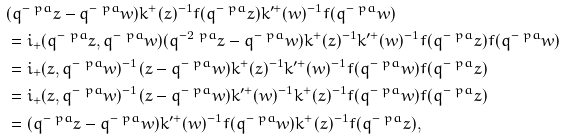<formula> <loc_0><loc_0><loc_500><loc_500>& ( q ^ { - \ p a } z - q ^ { - \ p a } w ) k ^ { + } ( z ) ^ { - 1 } f ( q ^ { - \ p a } z ) k ^ { \prime + } ( w ) ^ { - 1 } f ( q ^ { - \ p a } w ) \\ & = i _ { + } ( q ^ { - \ p a } z , q ^ { - \ p a } w ) ( q ^ { - 2 \ p a } z - q ^ { - \ p a } w ) k ^ { + } ( z ) ^ { - 1 } k ^ { \prime + } ( w ) ^ { - 1 } f ( q ^ { - \ p a } z ) f ( q ^ { - \ p a } w ) \\ & = i _ { + } ( z , q ^ { - \ p a } w ) ^ { - 1 } ( z - q ^ { - \ p a } w ) k ^ { + } ( z ) ^ { - 1 } k ^ { \prime + } ( w ) ^ { - 1 } f ( q ^ { - \ p a } w ) f ( q ^ { - \ p a } z ) \\ & = i _ { + } ( z , q ^ { - \ p a } w ) ^ { - 1 } ( z - q ^ { - \ p a } w ) k ^ { \prime + } ( w ) ^ { - 1 } k ^ { + } ( z ) ^ { - 1 } f ( q ^ { - \ p a } w ) f ( q ^ { - \ p a } z ) \\ & = ( q ^ { - \ p a } z - q ^ { - \ p a } w ) k ^ { \prime + } ( w ) ^ { - 1 } f ( q ^ { - \ p a } w ) k ^ { + } ( z ) ^ { - 1 } f ( q ^ { - \ p a } z ) ,</formula> 